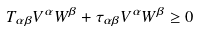<formula> <loc_0><loc_0><loc_500><loc_500>T _ { \alpha \beta } V ^ { \alpha } W ^ { \beta } + \tau _ { \alpha \beta } V ^ { \alpha } W ^ { \beta } \geq 0</formula> 